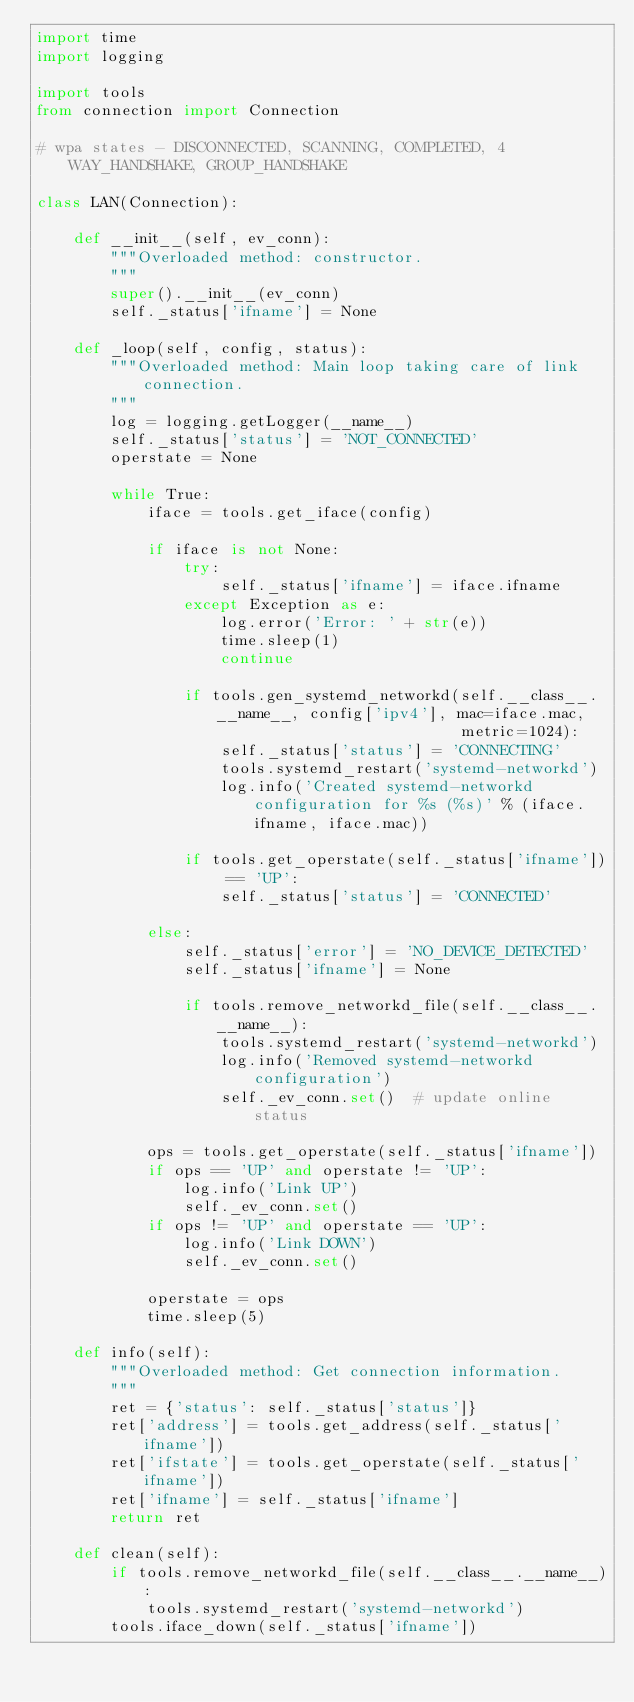Convert code to text. <code><loc_0><loc_0><loc_500><loc_500><_Python_>import time
import logging

import tools
from connection import Connection

# wpa states - DISCONNECTED, SCANNING, COMPLETED, 4WAY_HANDSHAKE, GROUP_HANDSHAKE

class LAN(Connection):

    def __init__(self, ev_conn):
        """Overloaded method: constructor.
        """
        super().__init__(ev_conn)
        self._status['ifname'] = None

    def _loop(self, config, status):
        """Overloaded method: Main loop taking care of link connection.
        """
        log = logging.getLogger(__name__)
        self._status['status'] = 'NOT_CONNECTED'
        operstate = None

        while True:
            iface = tools.get_iface(config)

            if iface is not None:
                try:
                    self._status['ifname'] = iface.ifname
                except Exception as e:
                    log.error('Error: ' + str(e))
                    time.sleep(1)
                    continue

                if tools.gen_systemd_networkd(self.__class__.__name__, config['ipv4'], mac=iface.mac,
                                              metric=1024):
                    self._status['status'] = 'CONNECTING'
                    tools.systemd_restart('systemd-networkd')
                    log.info('Created systemd-networkd configuration for %s (%s)' % (iface.ifname, iface.mac))

                if tools.get_operstate(self._status['ifname']) == 'UP':
                    self._status['status'] = 'CONNECTED'

            else:
                self._status['error'] = 'NO_DEVICE_DETECTED'
                self._status['ifname'] = None

                if tools.remove_networkd_file(self.__class__.__name__):
                    tools.systemd_restart('systemd-networkd')
                    log.info('Removed systemd-networkd configuration')
                    self._ev_conn.set()  # update online status

            ops = tools.get_operstate(self._status['ifname'])
            if ops == 'UP' and operstate != 'UP':
                log.info('Link UP')
                self._ev_conn.set()
            if ops != 'UP' and operstate == 'UP':
                log.info('Link DOWN')
                self._ev_conn.set()

            operstate = ops
            time.sleep(5)

    def info(self):
        """Overloaded method: Get connection information.
        """
        ret = {'status': self._status['status']}
        ret['address'] = tools.get_address(self._status['ifname'])
        ret['ifstate'] = tools.get_operstate(self._status['ifname'])
        ret['ifname'] = self._status['ifname']
        return ret

    def clean(self):
        if tools.remove_networkd_file(self.__class__.__name__):
            tools.systemd_restart('systemd-networkd')
        tools.iface_down(self._status['ifname'])
</code> 